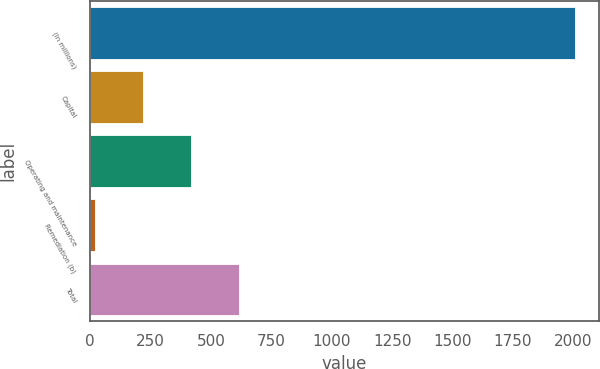Convert chart to OTSL. <chart><loc_0><loc_0><loc_500><loc_500><bar_chart><fcel>(In millions)<fcel>Capital<fcel>Operating and maintenance<fcel>Remediation (b)<fcel>Total<nl><fcel>2006<fcel>218.6<fcel>417.2<fcel>20<fcel>615.8<nl></chart> 